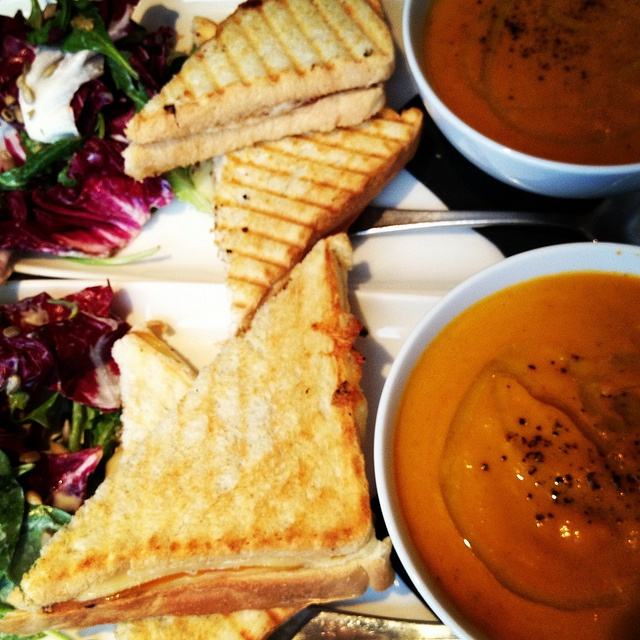Describe the objects in this image and their specific colors. I can see bowl in lightgray, maroon, and red tones, sandwich in lightgray, gold, khaki, and orange tones, bowl in lightgray, maroon, and lightblue tones, sandwich in lightgray, tan, and khaki tones, and sandwich in lightgray, khaki, and orange tones in this image. 